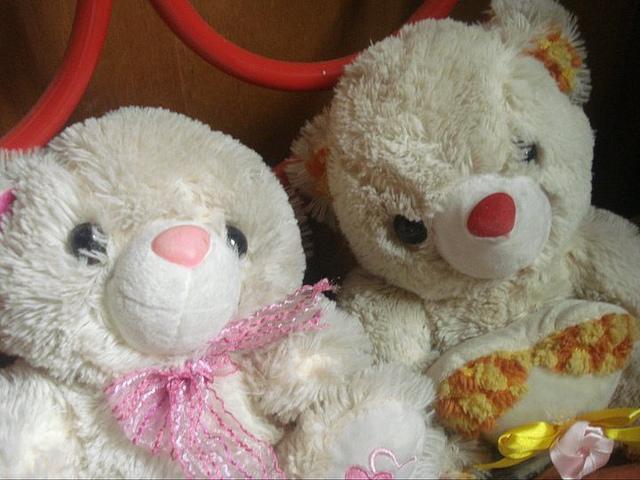How many teddy bears are there?
Give a very brief answer. 2. How many of the teddy bears eyes are shown in the photo?
Give a very brief answer. 4. How many teddy bears are in the picture?
Give a very brief answer. 2. 